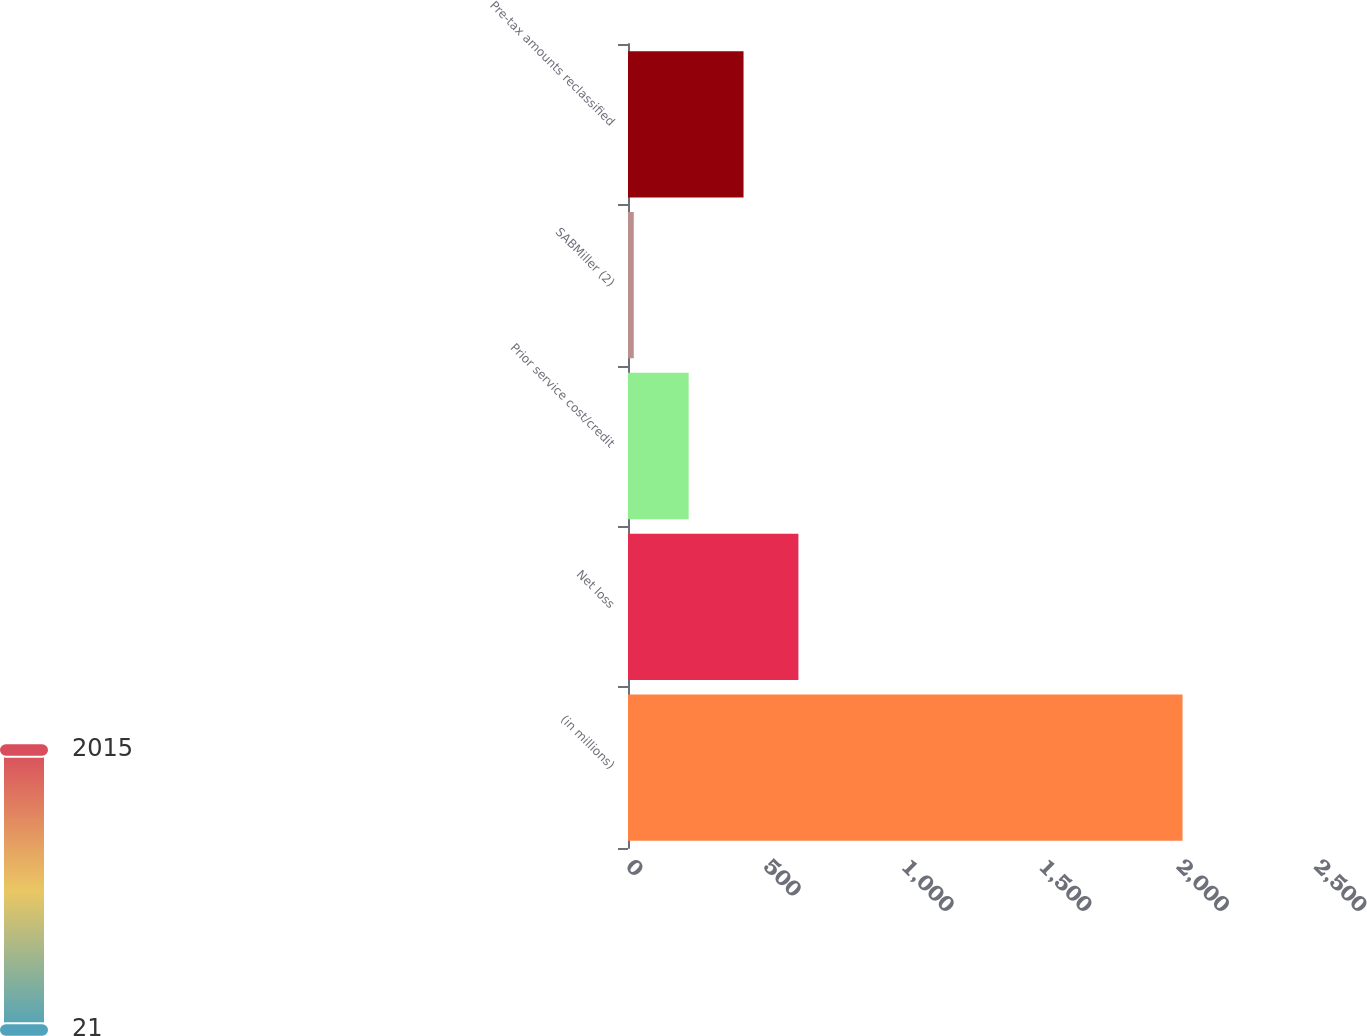Convert chart to OTSL. <chart><loc_0><loc_0><loc_500><loc_500><bar_chart><fcel>(in millions)<fcel>Net loss<fcel>Prior service cost/credit<fcel>SABMiller (2)<fcel>Pre-tax amounts reclassified<nl><fcel>2015<fcel>619.2<fcel>220.4<fcel>21<fcel>419.8<nl></chart> 